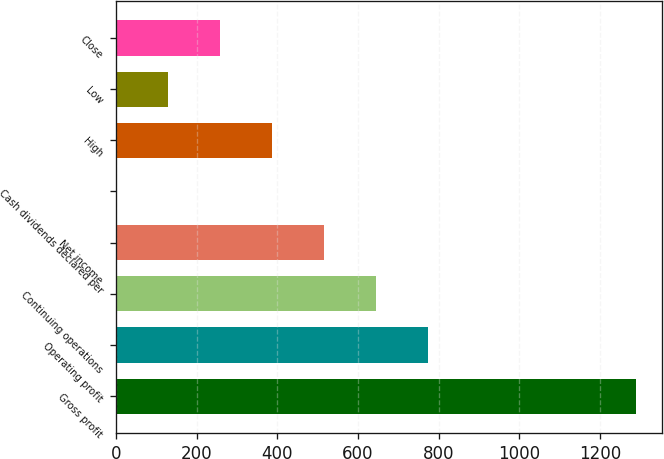Convert chart to OTSL. <chart><loc_0><loc_0><loc_500><loc_500><bar_chart><fcel>Gross profit<fcel>Operating profit<fcel>Continuing operations<fcel>Net income<fcel>Cash dividends declared per<fcel>High<fcel>Low<fcel>Close<nl><fcel>1289.6<fcel>773.92<fcel>645.01<fcel>516.1<fcel>0.45<fcel>387.18<fcel>129.36<fcel>258.27<nl></chart> 